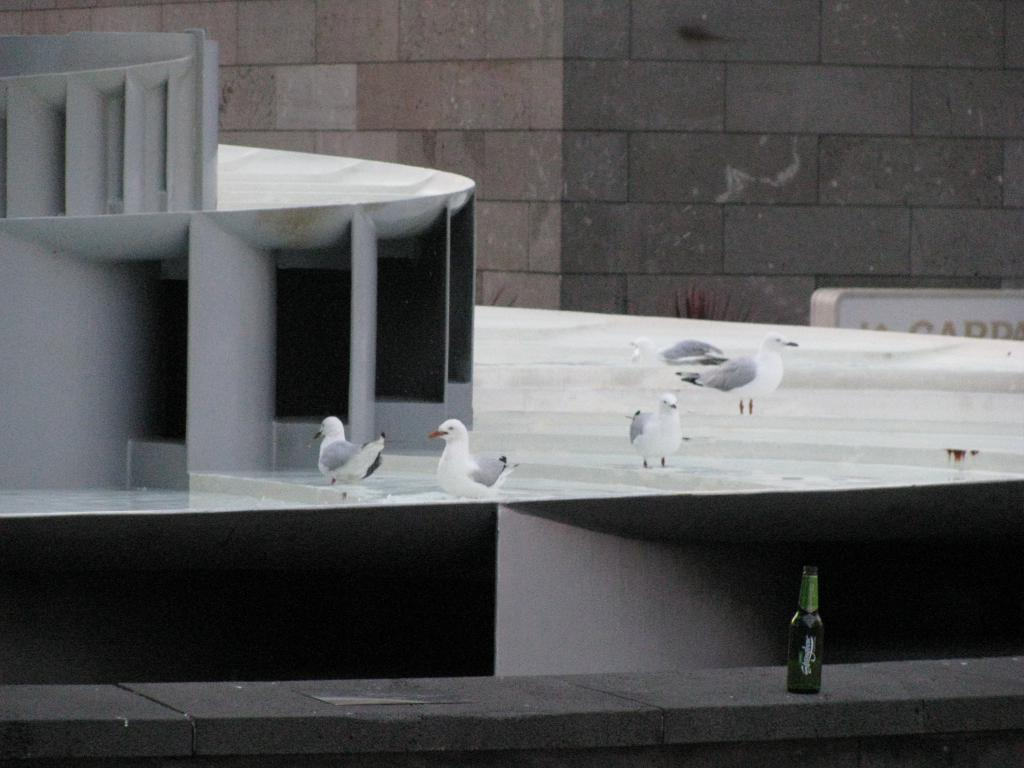What is the nature of the image? The image appears to be edited. What type of animals can be seen in the image? There are birds in the image. What architectural features are present in the image? There are pillars in the image. What object is placed on a platform in the image? There is a bottle on a platform in the image. What can be seen in the background of the image? In the background of the image, there is a wall and a board. What type of zipper can be seen on the birds in the image? There are no zippers present on the birds in the image. What type of needle is being used by the birds in the image? There are no needles present in the image, and the birds are not performing any actions that would require a needle. 